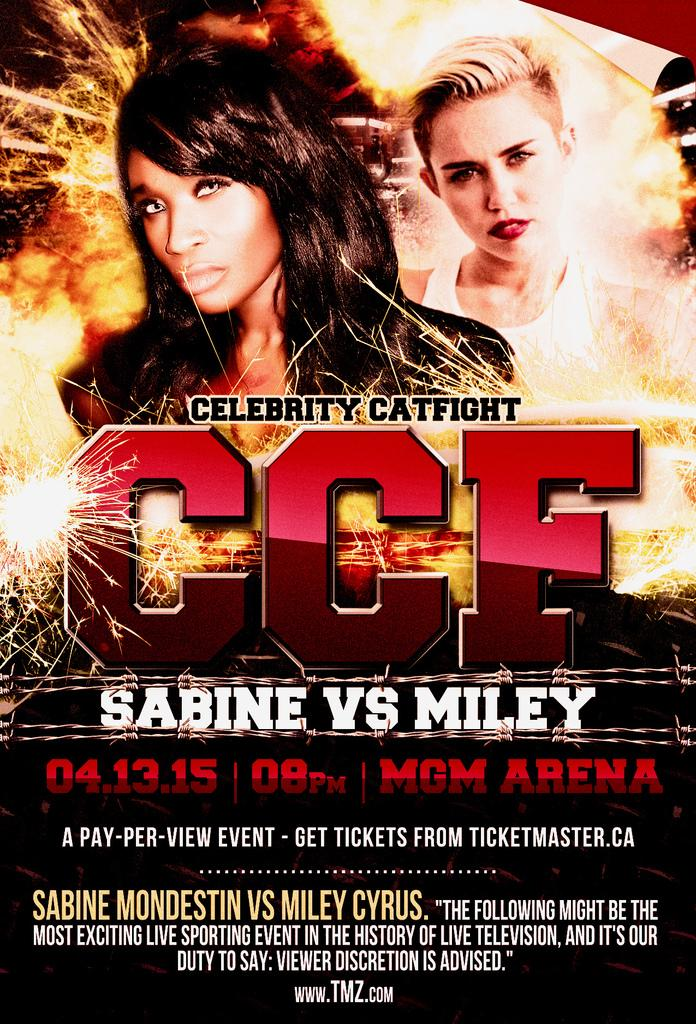<image>
Render a clear and concise summary of the photo. An advertisement for the Sabine Vs. Miley celebrity catfight. 